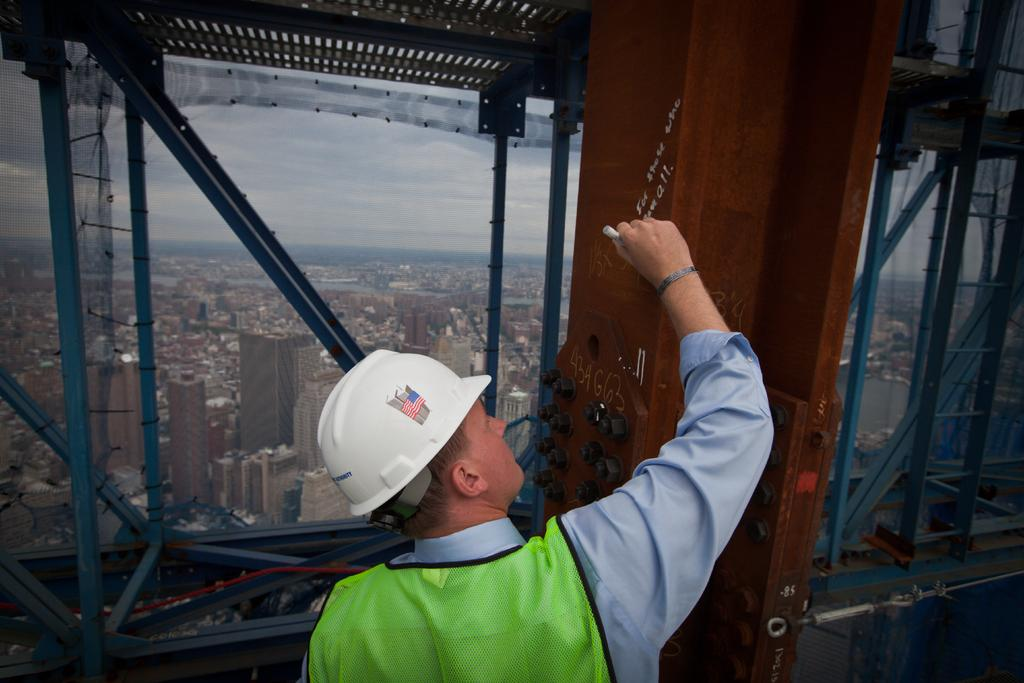What is the person in the image doing? The person is holding a marker and writing on a metal rod. What object is the person using to write? The person is using a marker to write. What can be seen in the background of the image? There are buildings in the background of the image. What type of meat is being served in the library in the image? There is no library or meat present in the image; it features a person writing on a metal rod with a marker and buildings in the background. 